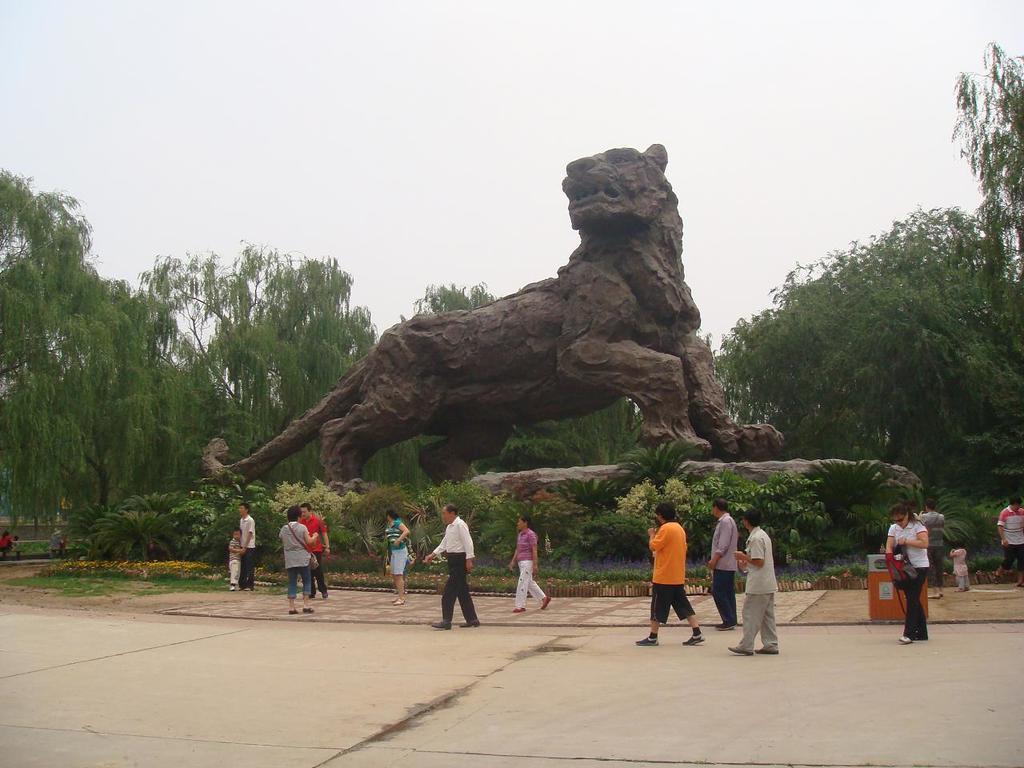How would you summarize this image in a sentence or two? In this picture there are people, among the few persons walking and we can see a sculpture of an animal on the platform, plants, trees and an object. In the background of the image we can see the sky. 